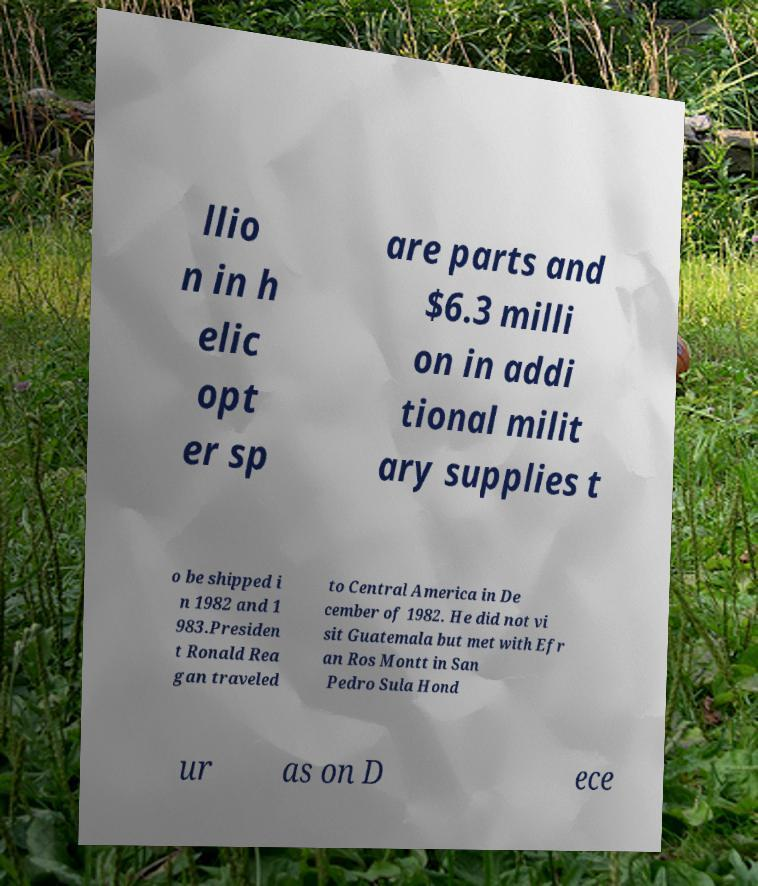Please read and relay the text visible in this image. What does it say? llio n in h elic opt er sp are parts and $6.3 milli on in addi tional milit ary supplies t o be shipped i n 1982 and 1 983.Presiden t Ronald Rea gan traveled to Central America in De cember of 1982. He did not vi sit Guatemala but met with Efr an Ros Montt in San Pedro Sula Hond ur as on D ece 